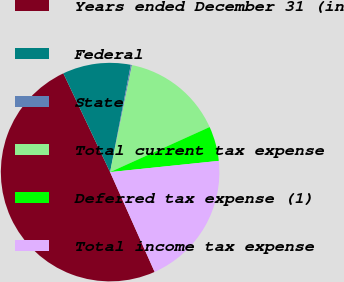Convert chart. <chart><loc_0><loc_0><loc_500><loc_500><pie_chart><fcel>Years ended December 31 (in<fcel>Federal<fcel>State<fcel>Total current tax expense<fcel>Deferred tax expense (1)<fcel>Total income tax expense<nl><fcel>49.64%<fcel>10.07%<fcel>0.18%<fcel>15.02%<fcel>5.13%<fcel>19.96%<nl></chart> 